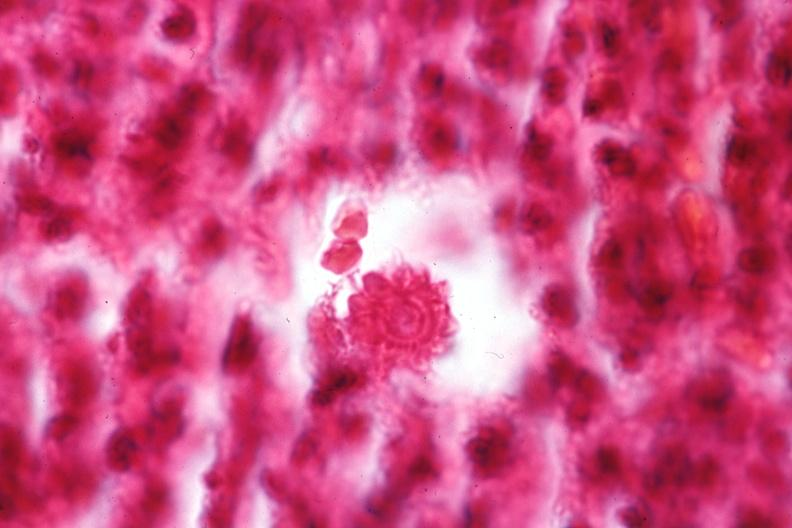what does this image show?
Answer the question using a single word or phrase. Oil immersion organism very well shown 